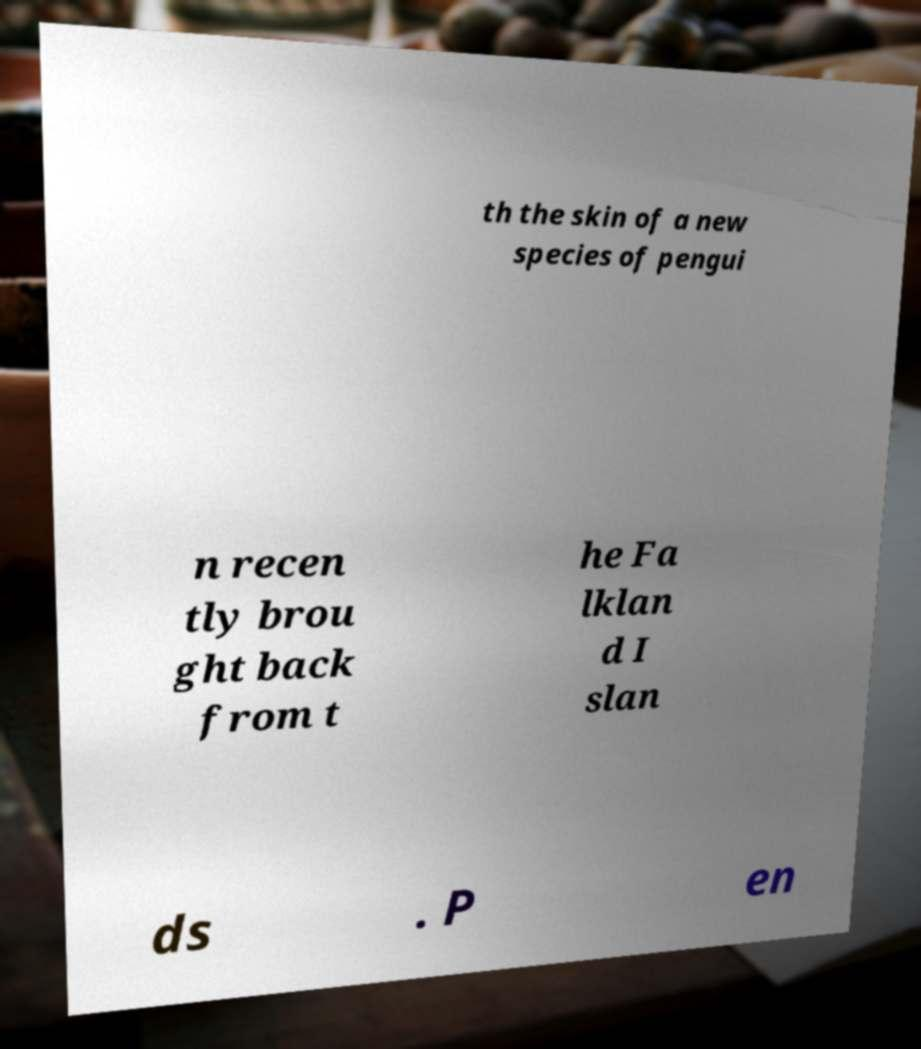Please identify and transcribe the text found in this image. th the skin of a new species of pengui n recen tly brou ght back from t he Fa lklan d I slan ds . P en 